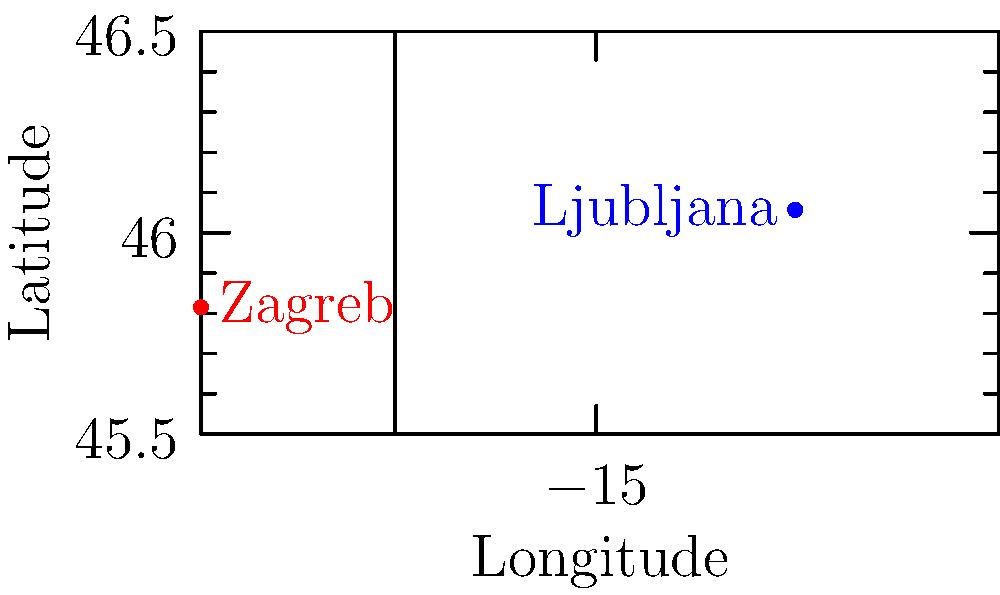While reminiscing about your high school days with Bibijana Čujec, you recall her mentioning her hometown of Ljubljana, Slovenia. Now living in Zagreb, Croatia, you're curious about the distance between these two cities. Given the coordinates of Zagreb (45.8150°N, 15.9819°E) and Ljubljana (46.0569°N, 14.5058°E), calculate the approximate distance between them using the Euclidean distance formula on a flat plane. (Note: Assume 1° of latitude = 111 km and 1° of longitude at this latitude ≈ 76 km) To solve this problem, we'll follow these steps:

1) First, let's identify the coordinates:
   Zagreb: (45.8150°N, 15.9819°E)
   Ljubljana: (46.0569°N, 14.5058°E)

2) Calculate the differences in latitude and longitude:
   Δlat = 46.0569° - 45.8150° = 0.2419°
   Δlon = 15.9819° - 14.5058° = 1.4761°

3) Convert these differences to kilometers:
   Δlat in km = 0.2419° × 111 km/° = 26.8509 km
   Δlon in km = 1.4761° × 76 km/° = 112.1836 km

4) Use the Euclidean distance formula:
   $$d = \sqrt{(\Delta lat)^2 + (\Delta lon)^2}$$

5) Plug in the values:
   $$d = \sqrt{(26.8509)^2 + (112.1836)^2}$$

6) Calculate:
   $$d = \sqrt{720.9708 + 12585.1603}$$
   $$d = \sqrt{13306.1311}$$
   $$d \approx 115.3522 \text{ km}$$

Therefore, the approximate distance between Zagreb and Ljubljana is about 115.35 km.
Answer: 115.35 km 